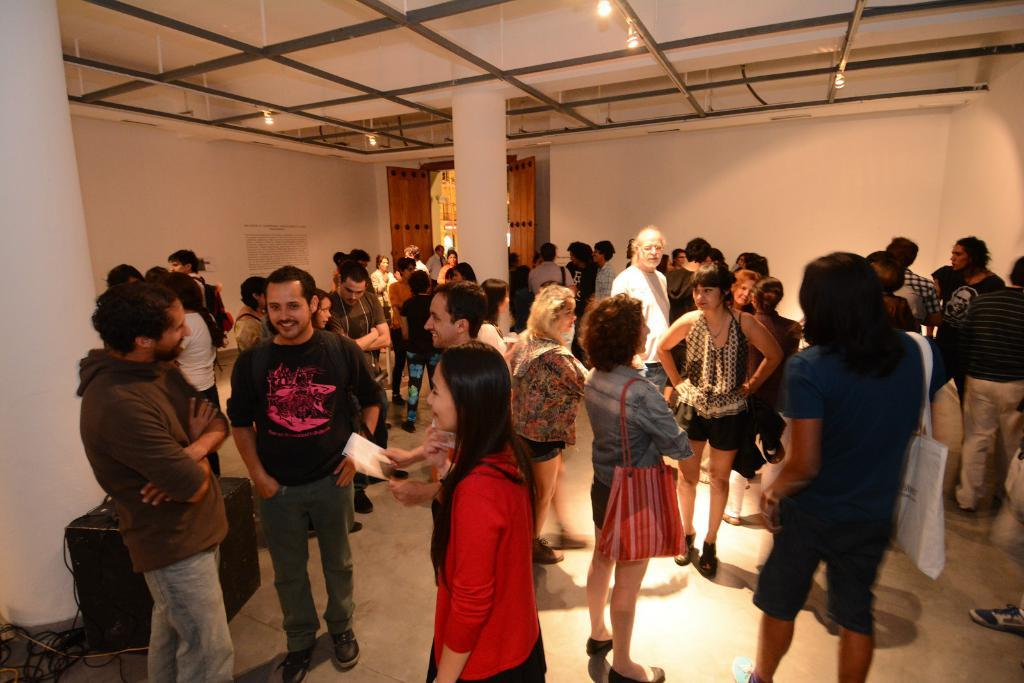What can be seen in the image involving people? There are people standing in the image. What type of structure is present in the image? There are iron grills in the image. What type of lighting is visible in the image? Electric lights are visible in the image. What type of entrance is present in the image? There is a door in the image. What type of informational display is present in the image? An information board is attached to a wall in the image. What type of wiring is present in the image? Cables are present in the image. What type of audio device is visible in the image? A speaker is visible in the image. Can you tell me how many sons are depicted in the image? There are no sons depicted in the image. What type of carriage is present in the image? There is no carriage present in the image. 